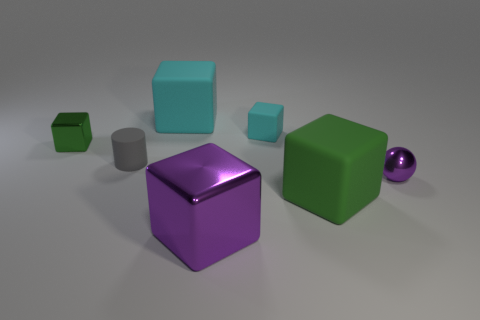Subtract all purple metal blocks. How many blocks are left? 4 Subtract all balls. How many objects are left? 6 Add 2 tiny rubber balls. How many objects exist? 9 Subtract all purple blocks. How many blocks are left? 4 Subtract all blue cylinders. Subtract all blue spheres. How many cylinders are left? 1 Subtract all blue spheres. How many red cylinders are left? 0 Subtract all cyan cubes. Subtract all tiny rubber objects. How many objects are left? 3 Add 1 green rubber objects. How many green rubber objects are left? 2 Add 5 large brown metallic spheres. How many large brown metallic spheres exist? 5 Subtract 0 cyan spheres. How many objects are left? 7 